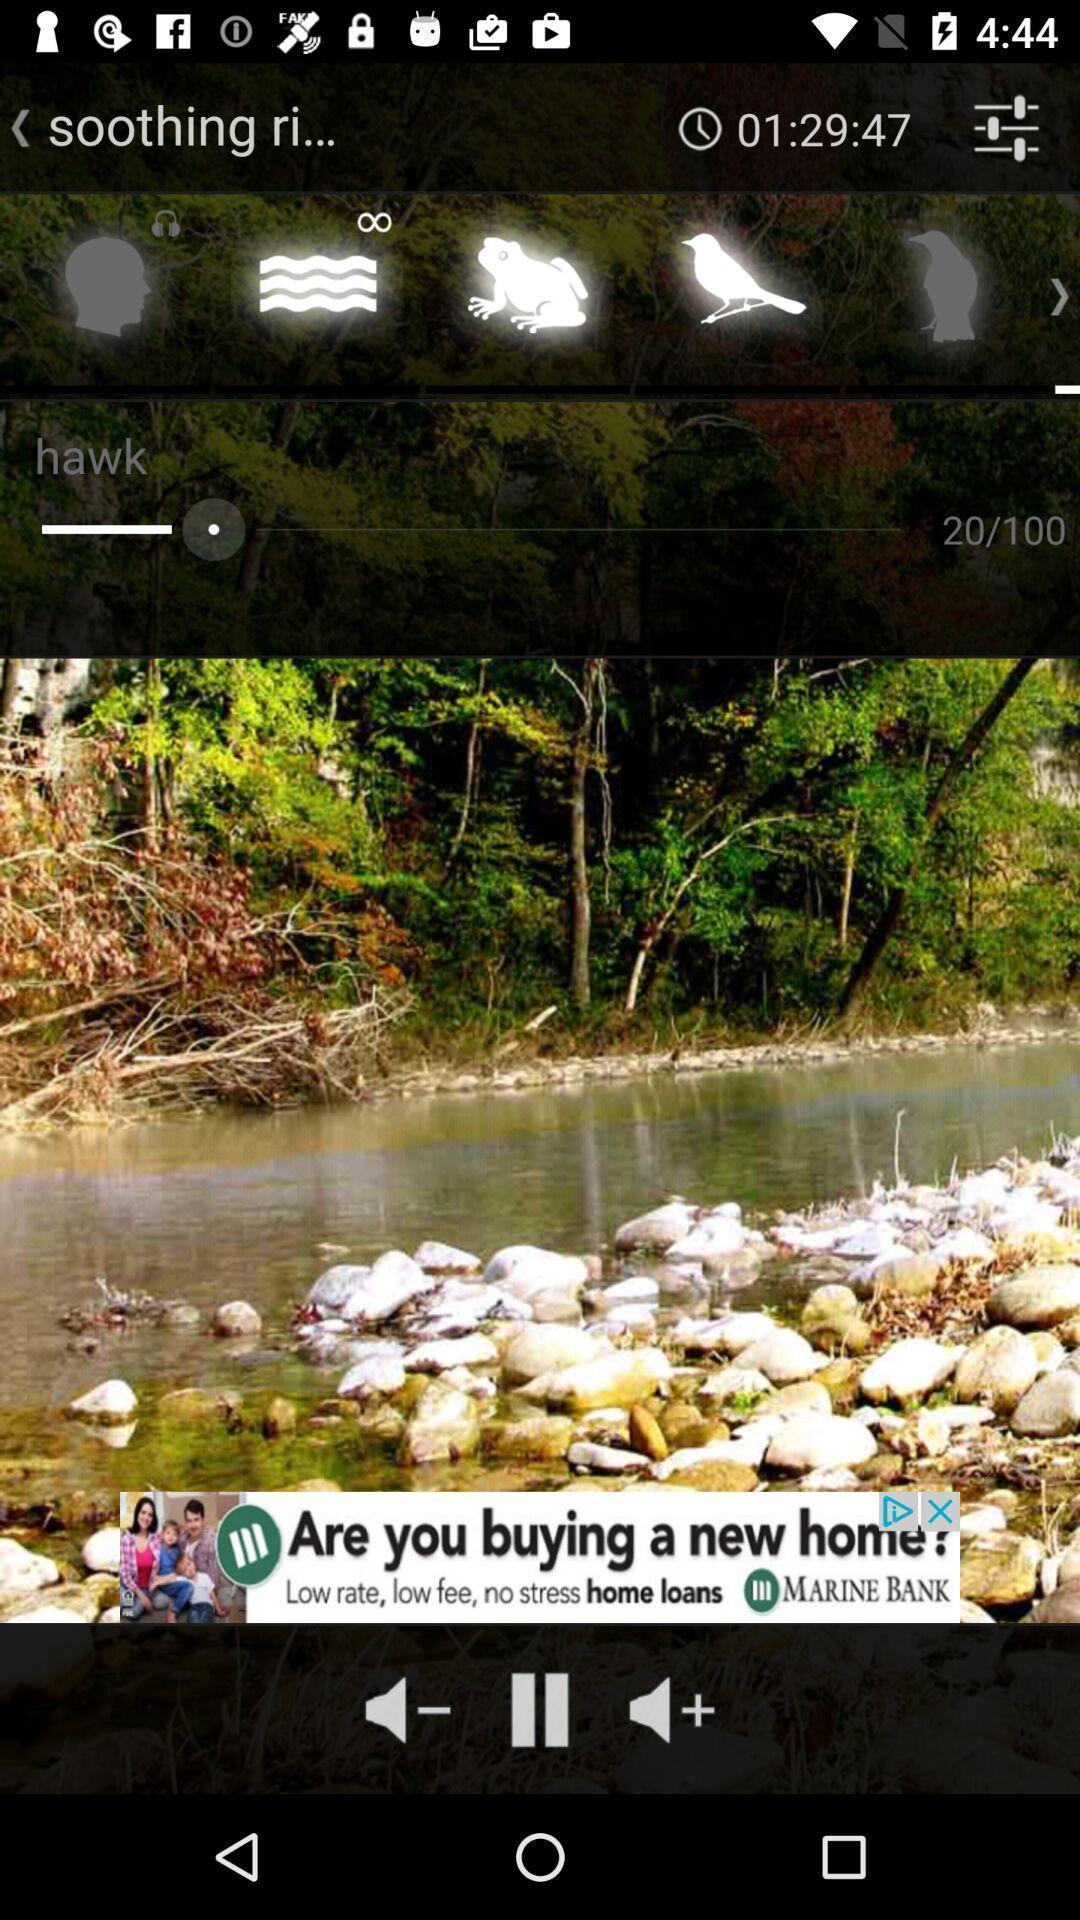Provide a detailed account of this screenshot. Page of a music player app. 